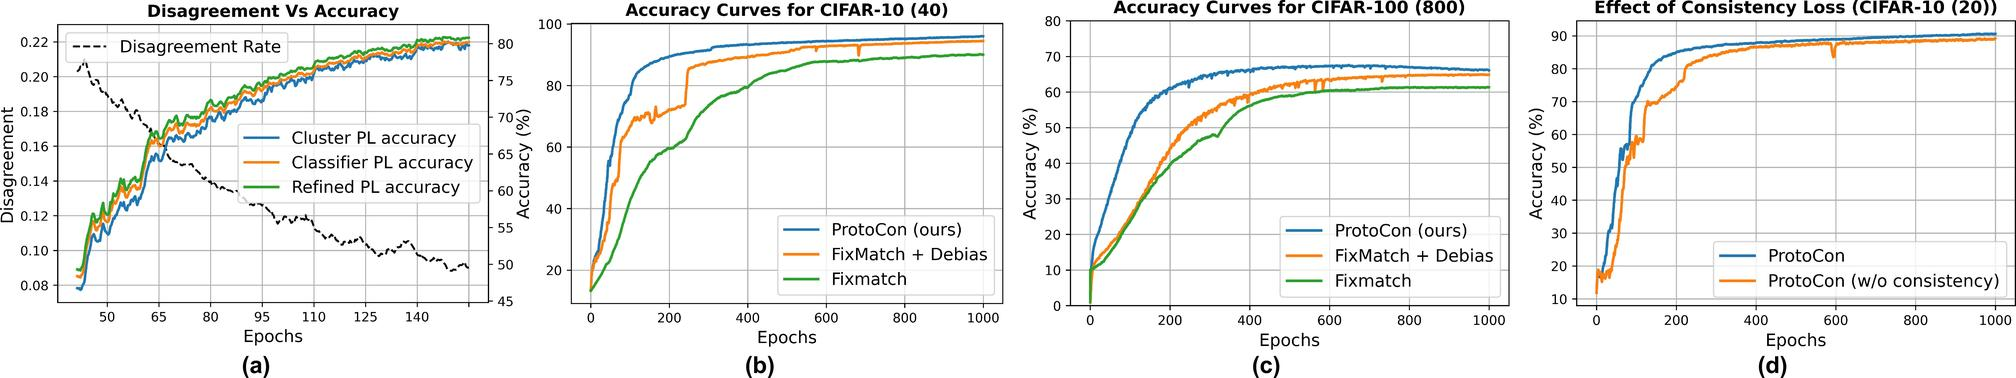What trend is observed in the Disagreement Rate as the number of epochs increases? A) The Disagreement Rate increases. B) The Disagreement Rate decreases. C) The Disagreement Rate remains constant. D) The Disagreement Rate fluctuates without a clear trend. ## Figure (b) The graph in figure (a) shows a downward trend in the Disagreement Rate as the number of epochs increases, indicating an improvement in agreement over time. Therefore, the correct answer is B. 